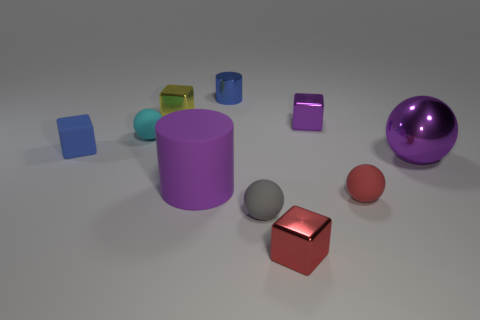Can you describe the lighting in this scene? The lighting in this scene is soft and diffused, coming from above. There are gentle shadows under the objects, indicating a single or multiple light sources positioned overhead, creating a calm and evenly lit setting. Does the lighting affect the colors of the objects? Yes, the soft lighting helps to bring out the rich colors of the objects, enhancing their hues without creating harsh highlights or shadows, which contributes to the clarity and vividness of the scene. 